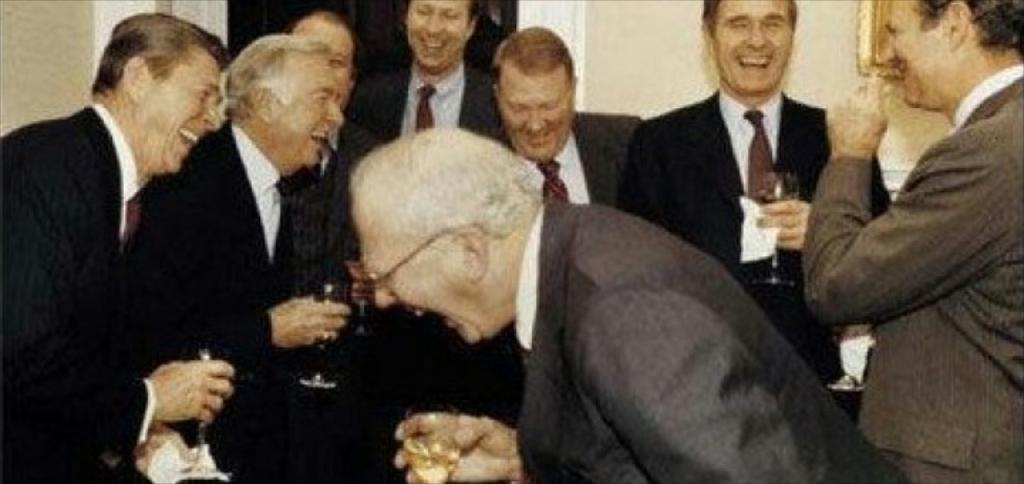Who is present in the image? There are people in the image. What are the people doing in the image? The people are laughing. What are some of the people holding in the image? Some of the people are holding glasses with drinks. Can you describe any objects in the image? There are objects in the image, but the specific details are not provided. What is on the wall on the right side of the image? There is a picture frame on the wall on the right side of the image. What color is the orange that the representative is holding in the image? There is no orange or representative present in the image. 